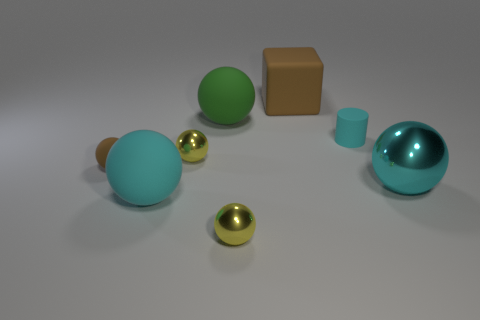How big is the thing that is in front of the large shiny sphere and right of the large green sphere?
Provide a short and direct response. Small. There is a metallic ball that is right of the large matte cube; does it have the same color as the tiny cylinder?
Your answer should be very brief. Yes. Are there fewer cyan objects to the left of the big matte cube than small brown matte objects?
Your response must be concise. No. There is a large brown object that is made of the same material as the tiny cylinder; what is its shape?
Give a very brief answer. Cube. Is the number of brown cubes in front of the large metal sphere less than the number of yellow metallic balls behind the tiny brown thing?
Your response must be concise. Yes. What size is the matte ball that is the same color as the large metallic sphere?
Your answer should be compact. Large. How many yellow objects are to the left of the yellow shiny sphere that is in front of the big cyan object that is left of the matte block?
Provide a short and direct response. 1. Is the color of the matte cylinder the same as the big metal sphere?
Make the answer very short. Yes. Are there any large matte things of the same color as the rubber cylinder?
Your response must be concise. Yes. The matte cylinder that is the same size as the brown rubber ball is what color?
Your response must be concise. Cyan. 